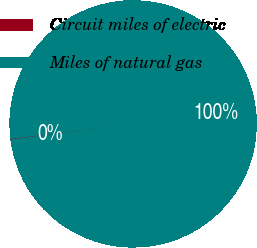<chart> <loc_0><loc_0><loc_500><loc_500><pie_chart><fcel>Circuit miles of electric<fcel>Miles of natural gas<nl><fcel>0.08%<fcel>99.92%<nl></chart> 